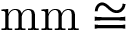Convert formula to latex. <formula><loc_0><loc_0><loc_500><loc_500>m m \cong</formula> 